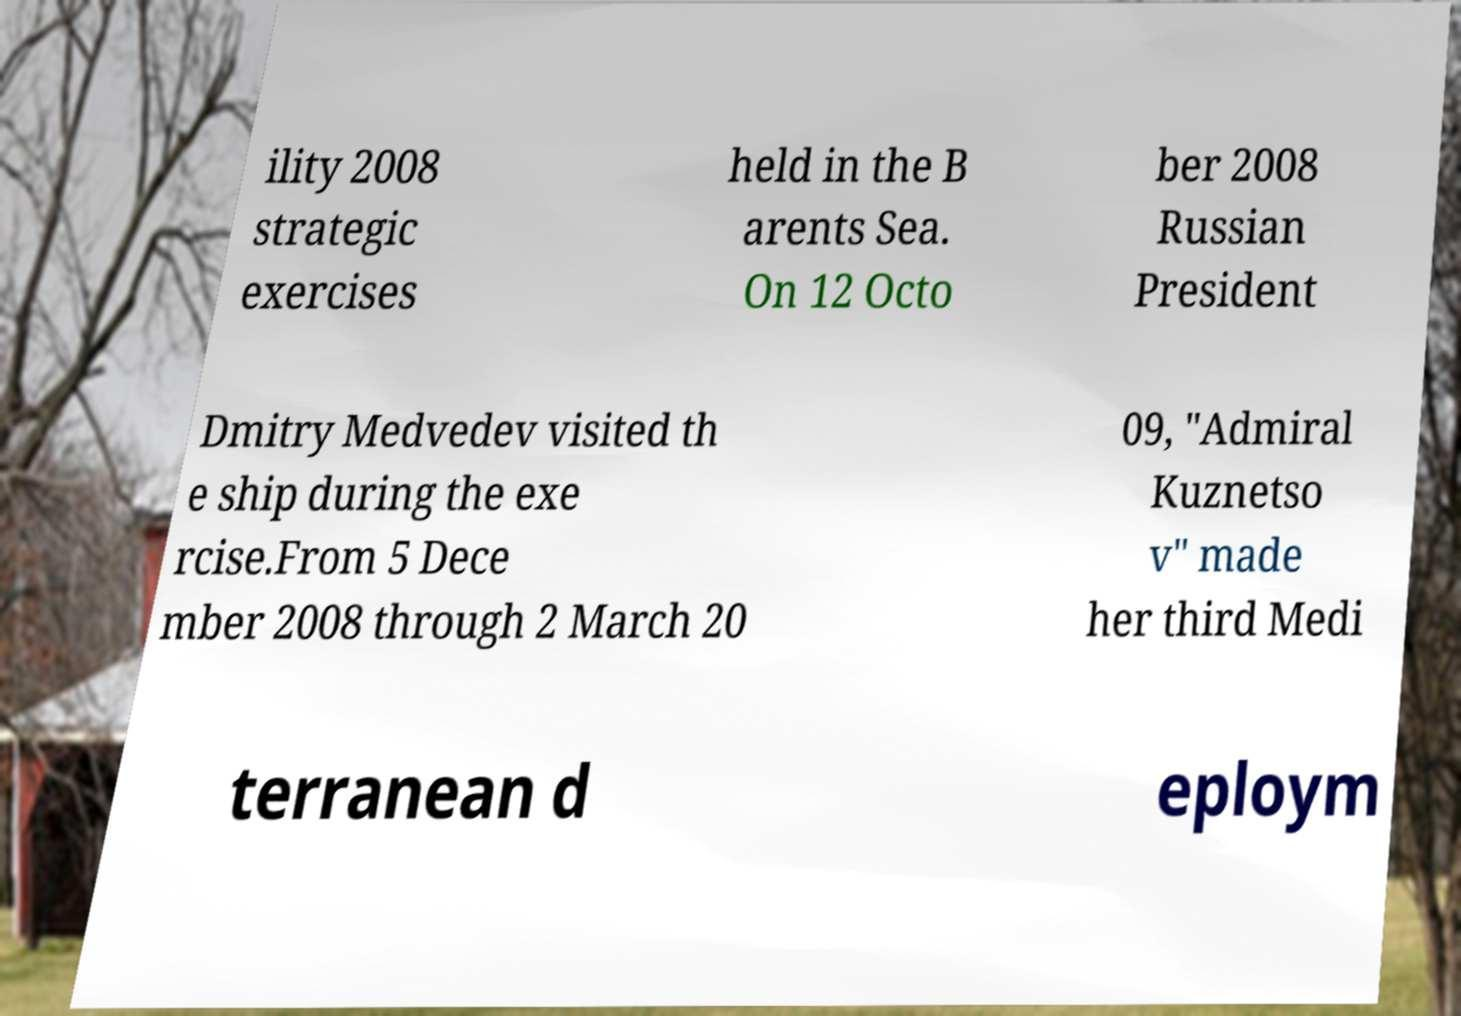I need the written content from this picture converted into text. Can you do that? ility 2008 strategic exercises held in the B arents Sea. On 12 Octo ber 2008 Russian President Dmitry Medvedev visited th e ship during the exe rcise.From 5 Dece mber 2008 through 2 March 20 09, "Admiral Kuznetso v" made her third Medi terranean d eploym 